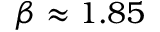Convert formula to latex. <formula><loc_0><loc_0><loc_500><loc_500>\beta \approx 1 . 8 5</formula> 